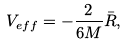<formula> <loc_0><loc_0><loc_500><loc_500>V _ { e f f } = - \frac { 2 } { 6 M } \bar { R } ,</formula> 